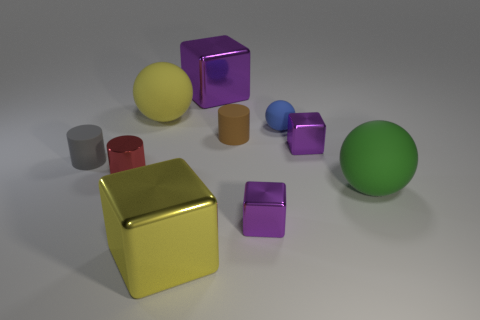Subtract all yellow cubes. How many cubes are left? 3 Subtract all blue balls. How many purple cubes are left? 3 Subtract 2 cubes. How many cubes are left? 2 Subtract all yellow blocks. How many blocks are left? 3 Subtract all gray balls. Subtract all red cylinders. How many balls are left? 3 Subtract all cylinders. How many objects are left? 7 Subtract all small purple metallic objects. Subtract all yellow objects. How many objects are left? 6 Add 4 tiny shiny blocks. How many tiny shiny blocks are left? 6 Add 2 blue matte balls. How many blue matte balls exist? 3 Subtract 0 gray spheres. How many objects are left? 10 